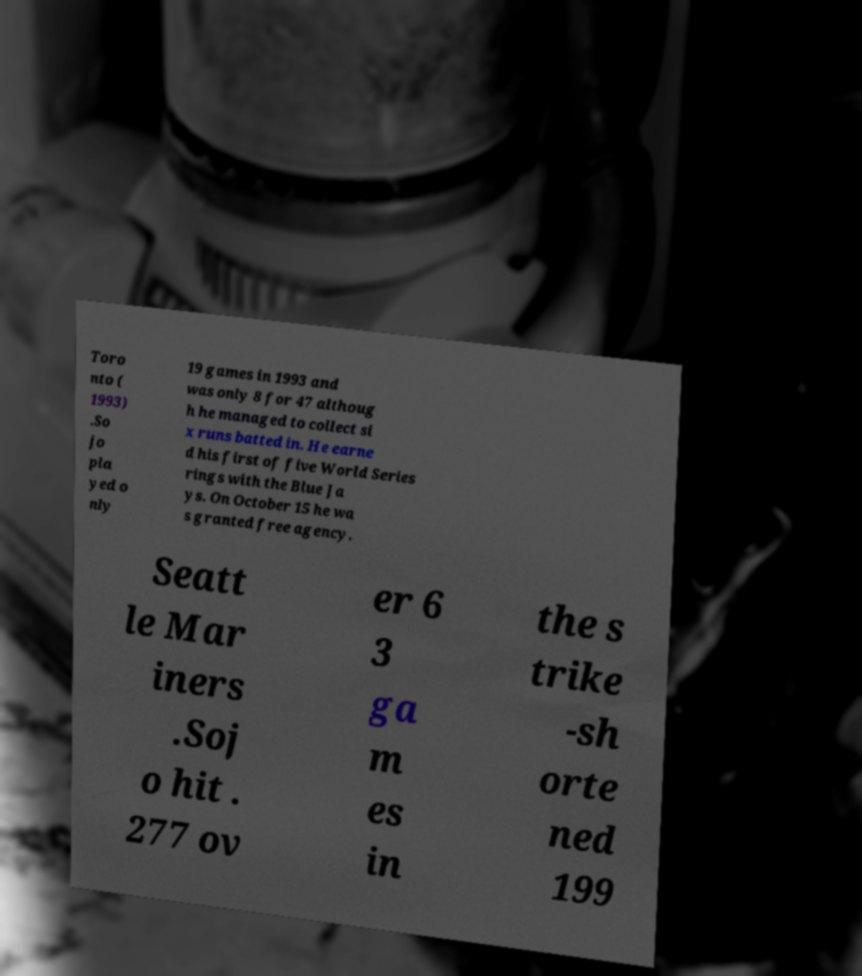Can you read and provide the text displayed in the image?This photo seems to have some interesting text. Can you extract and type it out for me? Toro nto ( 1993) .So jo pla yed o nly 19 games in 1993 and was only 8 for 47 althoug h he managed to collect si x runs batted in. He earne d his first of five World Series rings with the Blue Ja ys. On October 15 he wa s granted free agency. Seatt le Mar iners .Soj o hit . 277 ov er 6 3 ga m es in the s trike -sh orte ned 199 